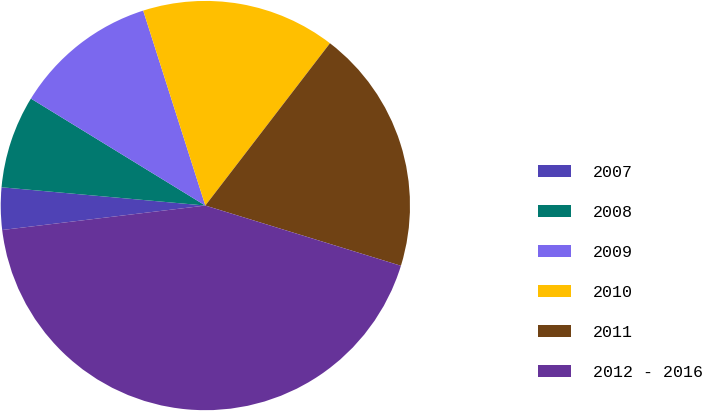Convert chart. <chart><loc_0><loc_0><loc_500><loc_500><pie_chart><fcel>2007<fcel>2008<fcel>2009<fcel>2010<fcel>2011<fcel>2012 - 2016<nl><fcel>3.33%<fcel>7.33%<fcel>11.33%<fcel>15.33%<fcel>19.33%<fcel>43.33%<nl></chart> 